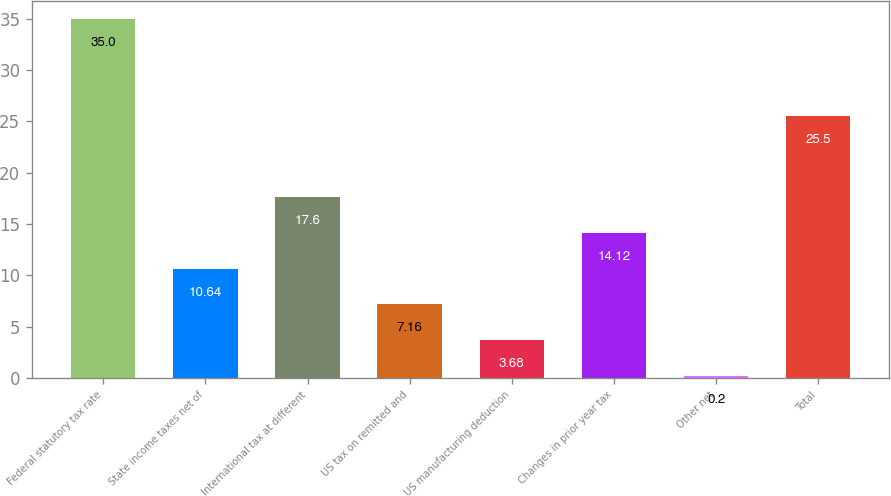<chart> <loc_0><loc_0><loc_500><loc_500><bar_chart><fcel>Federal statutory tax rate<fcel>State income taxes net of<fcel>International tax at different<fcel>US tax on remitted and<fcel>US manufacturing deduction<fcel>Changes in prior year tax<fcel>Other net<fcel>Total<nl><fcel>35<fcel>10.64<fcel>17.6<fcel>7.16<fcel>3.68<fcel>14.12<fcel>0.2<fcel>25.5<nl></chart> 